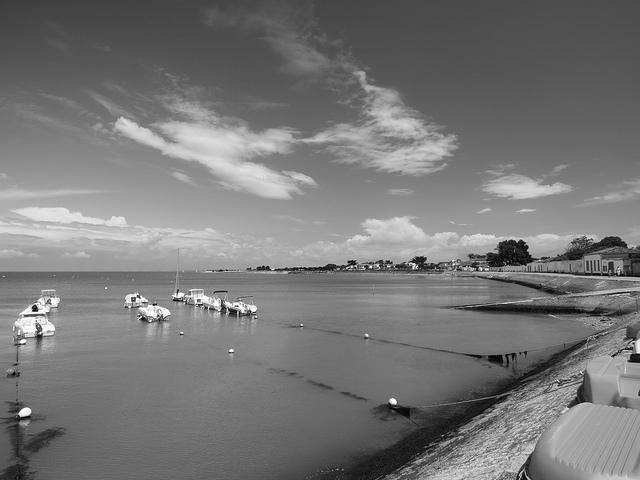How many boats are in this picture?
Give a very brief answer. 8. 